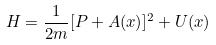<formula> <loc_0><loc_0><loc_500><loc_500>H = \frac { 1 } { 2 m } [ P + A ( x ) ] ^ { 2 } + U ( x )</formula> 